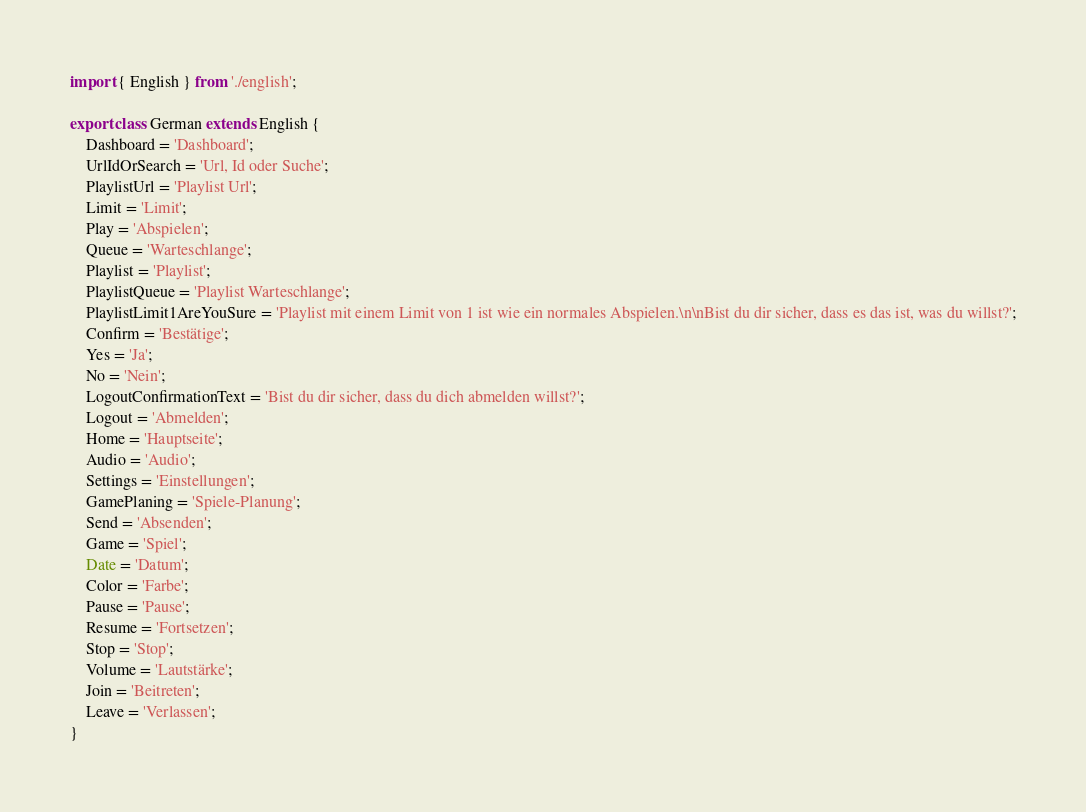Convert code to text. <code><loc_0><loc_0><loc_500><loc_500><_TypeScript_>import { English } from './english';

export class German extends English {
    Dashboard = 'Dashboard';
    UrlIdOrSearch = 'Url, Id oder Suche';
    PlaylistUrl = 'Playlist Url';
    Limit = 'Limit';
    Play = 'Abspielen';
    Queue = 'Warteschlange';
    Playlist = 'Playlist';
    PlaylistQueue = 'Playlist Warteschlange';
    PlaylistLimit1AreYouSure = 'Playlist mit einem Limit von 1 ist wie ein normales Abspielen.\n\nBist du dir sicher, dass es das ist, was du willst?';
    Confirm = 'Bestätige';
    Yes = 'Ja';
    No = 'Nein';
    LogoutConfirmationText = 'Bist du dir sicher, dass du dich abmelden willst?';
    Logout = 'Abmelden';
    Home = 'Hauptseite';
    Audio = 'Audio';
    Settings = 'Einstellungen';
    GamePlaning = 'Spiele-Planung';
    Send = 'Absenden';
    Game = 'Spiel';
    Date = 'Datum';
    Color = 'Farbe';
    Pause = 'Pause';
    Resume = 'Fortsetzen';
    Stop = 'Stop';
    Volume = 'Lautstärke';
    Join = 'Beitreten';
    Leave = 'Verlassen';
}
</code> 